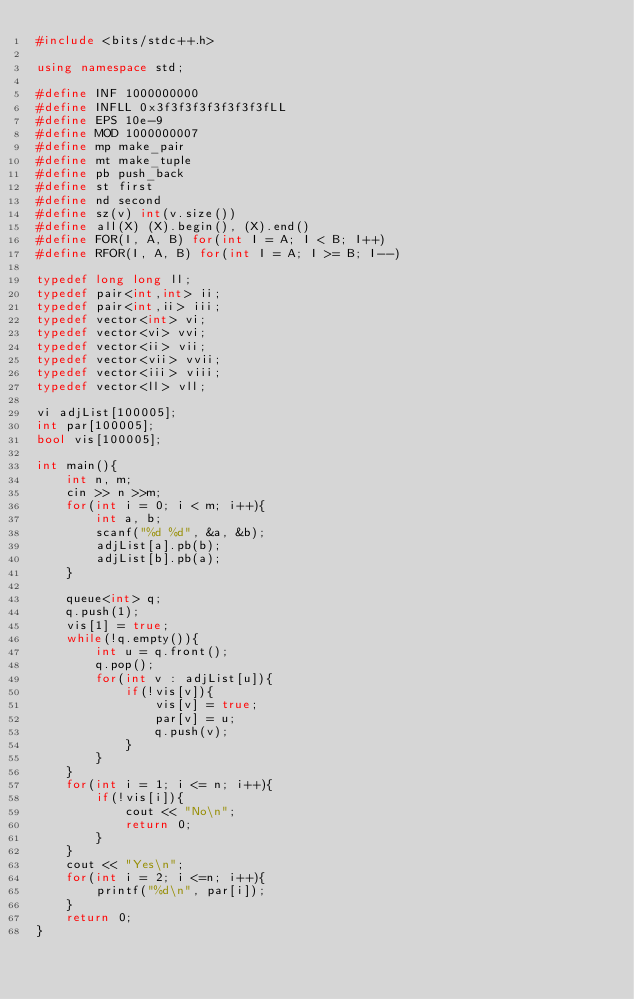Convert code to text. <code><loc_0><loc_0><loc_500><loc_500><_C++_>#include <bits/stdc++.h>

using namespace std;

#define INF 1000000000
#define INFLL 0x3f3f3f3f3f3f3f3fLL 
#define EPS 10e-9
#define MOD 1000000007
#define mp make_pair
#define mt make_tuple
#define pb push_back
#define st first
#define nd second
#define sz(v) int(v.size())
#define all(X) (X).begin(), (X).end()
#define FOR(I, A, B) for(int I = A; I < B; I++)
#define RFOR(I, A, B) for(int I = A; I >= B; I--)

typedef long long ll;
typedef pair<int,int> ii;
typedef pair<int,ii> iii;
typedef vector<int> vi;
typedef vector<vi> vvi;
typedef vector<ii> vii;
typedef vector<vii> vvii;
typedef vector<iii> viii;
typedef vector<ll> vll;

vi adjList[100005];
int par[100005];
bool vis[100005];

int main(){
	int n, m;
	cin >> n >>m;
	for(int i = 0; i < m; i++){
		int a, b;
		scanf("%d %d", &a, &b);
		adjList[a].pb(b);
		adjList[b].pb(a);
	}

	queue<int> q;
	q.push(1);
	vis[1] = true;
	while(!q.empty()){
		int u = q.front();
		q.pop();
		for(int v : adjList[u]){
			if(!vis[v]){
				vis[v] = true;
				par[v] = u;
				q.push(v);
			}
		}
	}
	for(int i = 1; i <= n; i++){
		if(!vis[i]){
			cout << "No\n";
			return 0;
		}
	}
	cout << "Yes\n";
	for(int i = 2; i <=n; i++){
		printf("%d\n", par[i]);
	}
	return 0;
}

</code> 